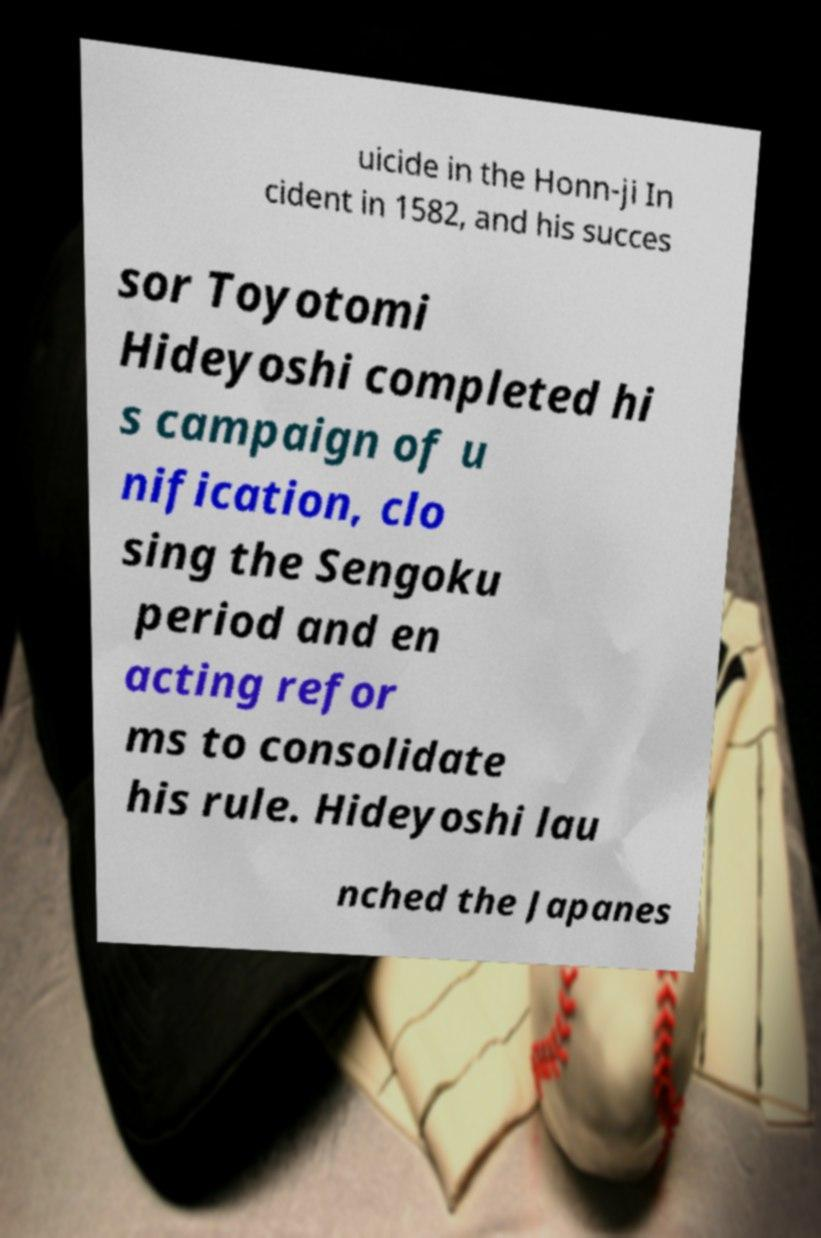There's text embedded in this image that I need extracted. Can you transcribe it verbatim? uicide in the Honn-ji In cident in 1582, and his succes sor Toyotomi Hideyoshi completed hi s campaign of u nification, clo sing the Sengoku period and en acting refor ms to consolidate his rule. Hideyoshi lau nched the Japanes 